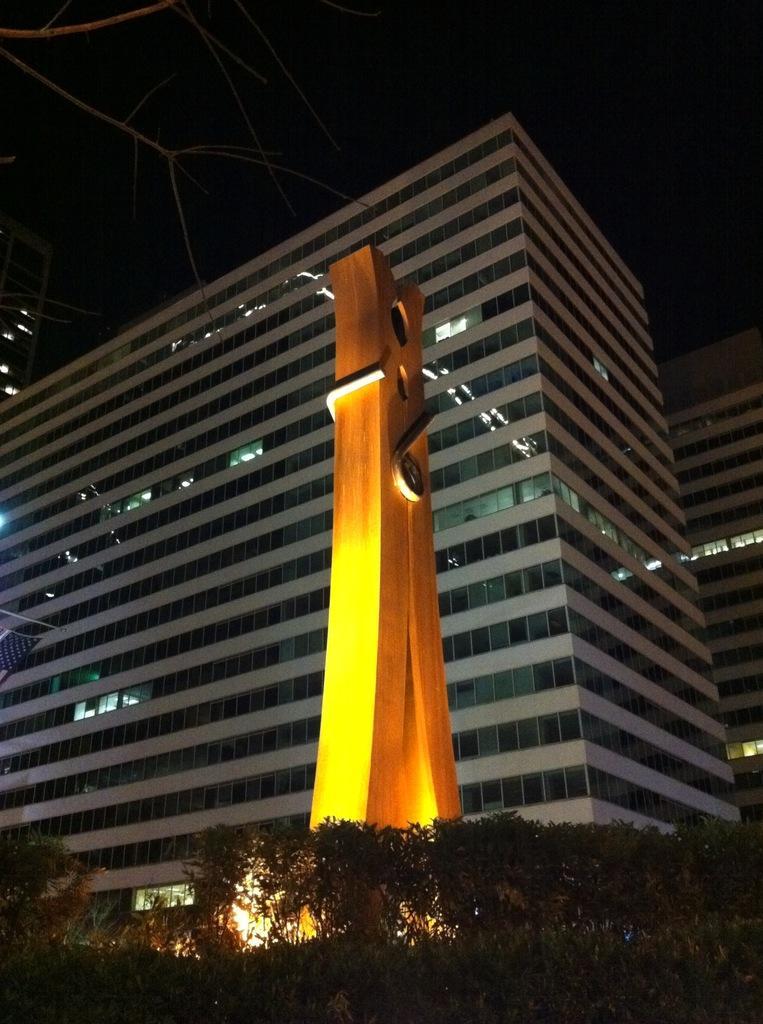Could you give a brief overview of what you see in this image? In the center of the image we can see a statue. In the foreground we can see a group of trees. In the background, we can see a building and the sky. 